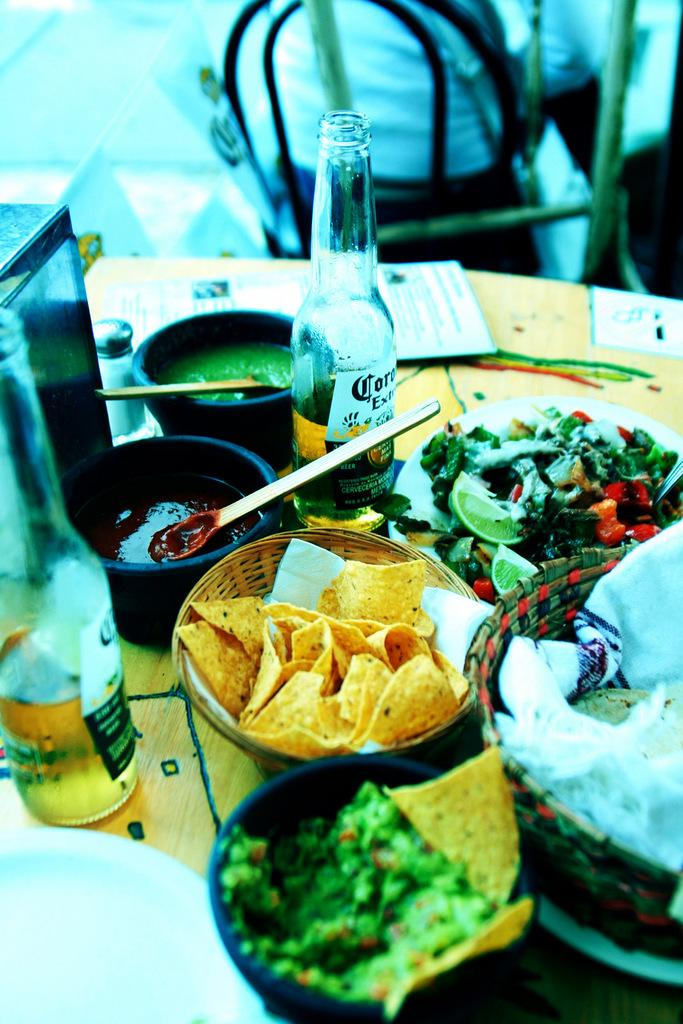<image>
Create a compact narrative representing the image presented. A bottle with a label that shows, "cor" its on a table next to chips on a table. 